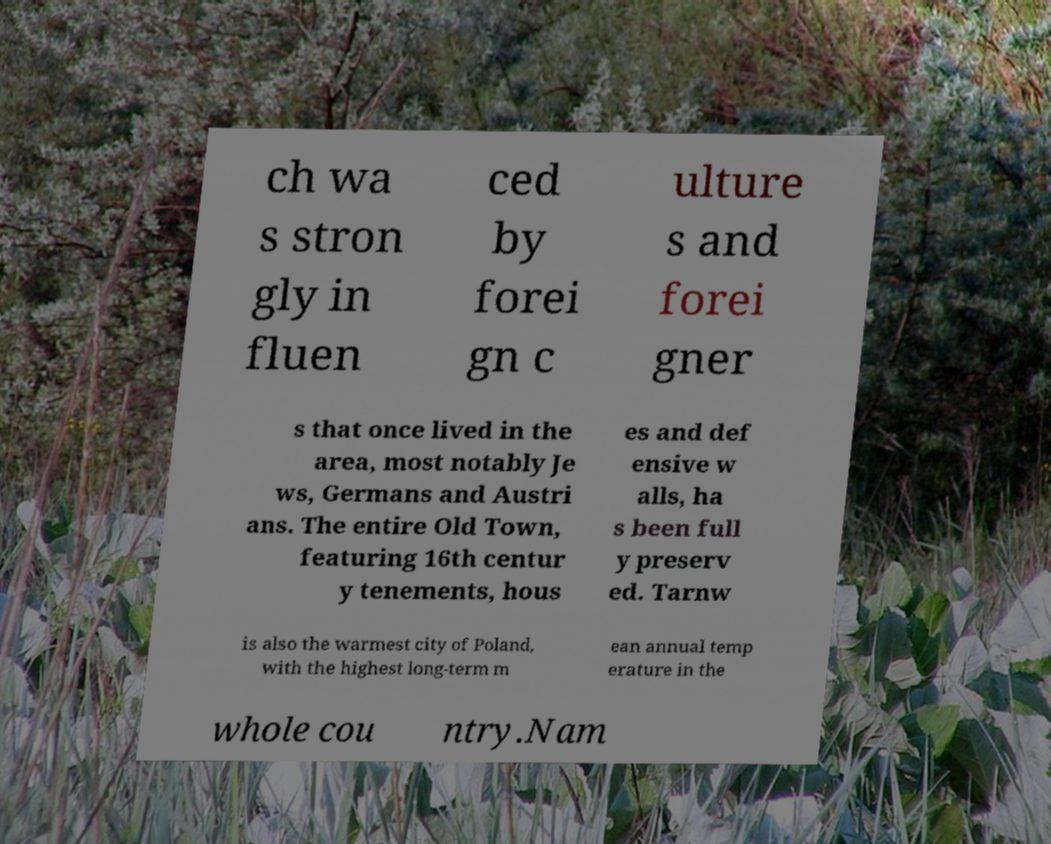Please identify and transcribe the text found in this image. ch wa s stron gly in fluen ced by forei gn c ulture s and forei gner s that once lived in the area, most notably Je ws, Germans and Austri ans. The entire Old Town, featuring 16th centur y tenements, hous es and def ensive w alls, ha s been full y preserv ed. Tarnw is also the warmest city of Poland, with the highest long-term m ean annual temp erature in the whole cou ntry.Nam 